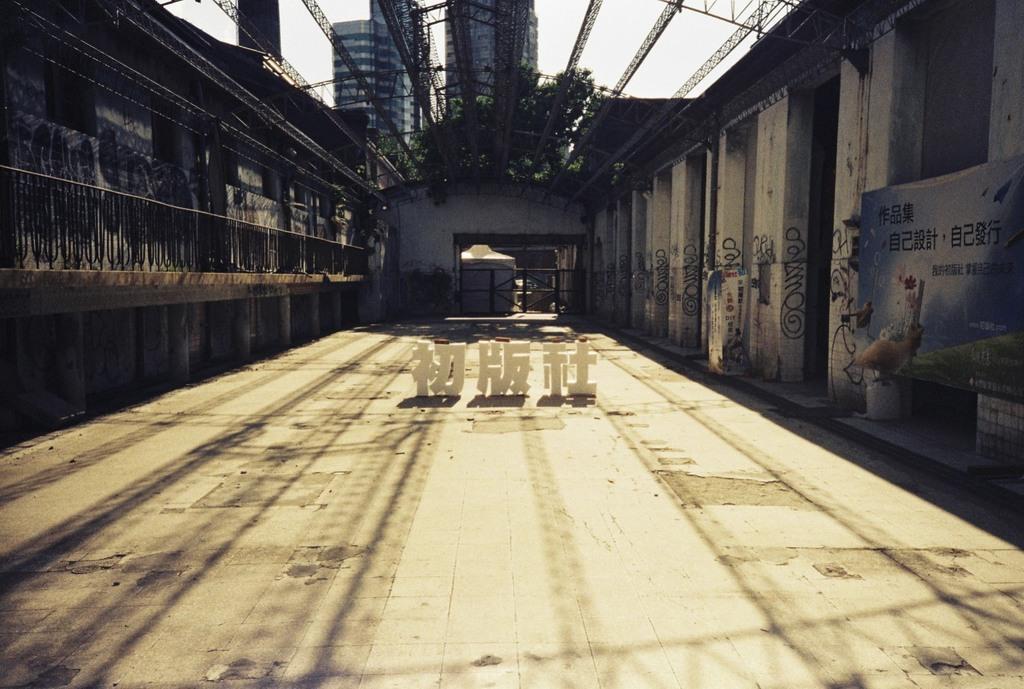Describe this image in one or two sentences. In this picture we can see a few objects on the path. There are the reflections of some objects visible on this path. We can see a few pillars on the right and left side of the image. There is some text visible on the pillars. We can see some railing on the left side. There are a few plants visible on the steel objects which are on top. We can see the buildings in the background. 